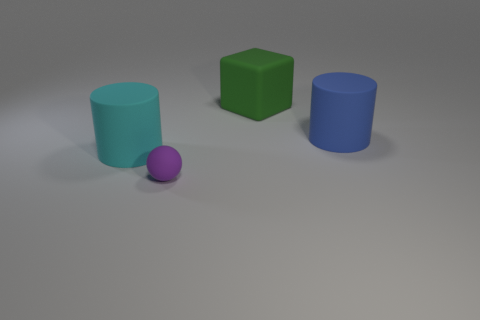Add 1 big gray cylinders. How many objects exist? 5 Subtract all blocks. How many objects are left? 3 Subtract all red shiny blocks. Subtract all big green things. How many objects are left? 3 Add 3 green cubes. How many green cubes are left? 4 Add 3 tiny things. How many tiny things exist? 4 Subtract 0 red cubes. How many objects are left? 4 